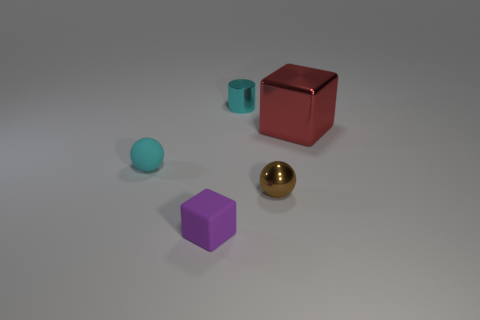Is there a yellow matte cylinder that has the same size as the purple cube?
Your answer should be very brief. No. Is the number of yellow metallic spheres less than the number of tiny purple rubber blocks?
Your response must be concise. Yes. What is the shape of the cyan object in front of the metal thing behind the block to the right of the small brown ball?
Give a very brief answer. Sphere. How many objects are purple objects that are left of the red shiny object or blocks left of the small shiny cylinder?
Your answer should be very brief. 1. There is a small purple cube; are there any big red metal things to the left of it?
Provide a succinct answer. No. How many things are small cyan objects that are behind the red shiny cube or blue blocks?
Provide a succinct answer. 1. How many purple things are either large things or small metallic cylinders?
Your answer should be compact. 0. What number of other things are there of the same color as the tiny block?
Keep it short and to the point. 0. Is the number of tiny metal cylinders to the right of the red object less than the number of red rubber things?
Keep it short and to the point. No. The tiny metal thing behind the block that is on the right side of the small object that is behind the cyan matte ball is what color?
Keep it short and to the point. Cyan. 